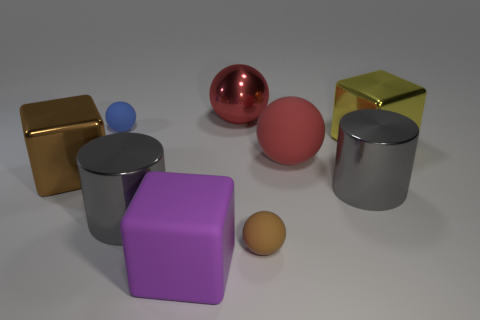Are there more objects that are behind the large brown metal thing than large cylinders?
Provide a short and direct response. Yes. What number of metal balls have the same size as the brown block?
Your response must be concise. 1. Is the size of the gray object to the right of the big purple cube the same as the gray metallic thing to the left of the brown rubber sphere?
Provide a short and direct response. Yes. Is the number of large gray objects that are to the right of the purple thing greater than the number of large red shiny objects that are to the right of the big yellow thing?
Provide a succinct answer. Yes. What number of big matte things are the same shape as the brown shiny object?
Your response must be concise. 1. What is the material of the brown block that is the same size as the yellow block?
Give a very brief answer. Metal. Are there any tiny blue objects that have the same material as the brown ball?
Your answer should be very brief. Yes. Are there fewer large brown things that are on the left side of the big brown block than big gray cylinders?
Offer a very short reply. Yes. There is a small ball in front of the gray cylinder on the right side of the big shiny ball; what is its material?
Your response must be concise. Rubber. What is the shape of the large metal thing that is both in front of the large yellow block and right of the large purple object?
Your answer should be compact. Cylinder. 